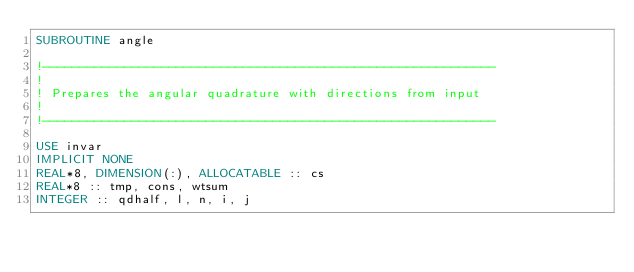Convert code to text. <code><loc_0><loc_0><loc_500><loc_500><_FORTRAN_>SUBROUTINE angle

!-------------------------------------------------------------
!
! Prepares the angular quadrature with directions from input
!
!-------------------------------------------------------------

USE invar
IMPLICIT NONE
REAL*8, DIMENSION(:), ALLOCATABLE :: cs
REAL*8 :: tmp, cons, wtsum
INTEGER :: qdhalf, l, n, i, j
</code> 